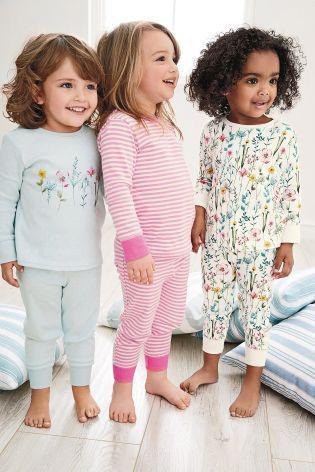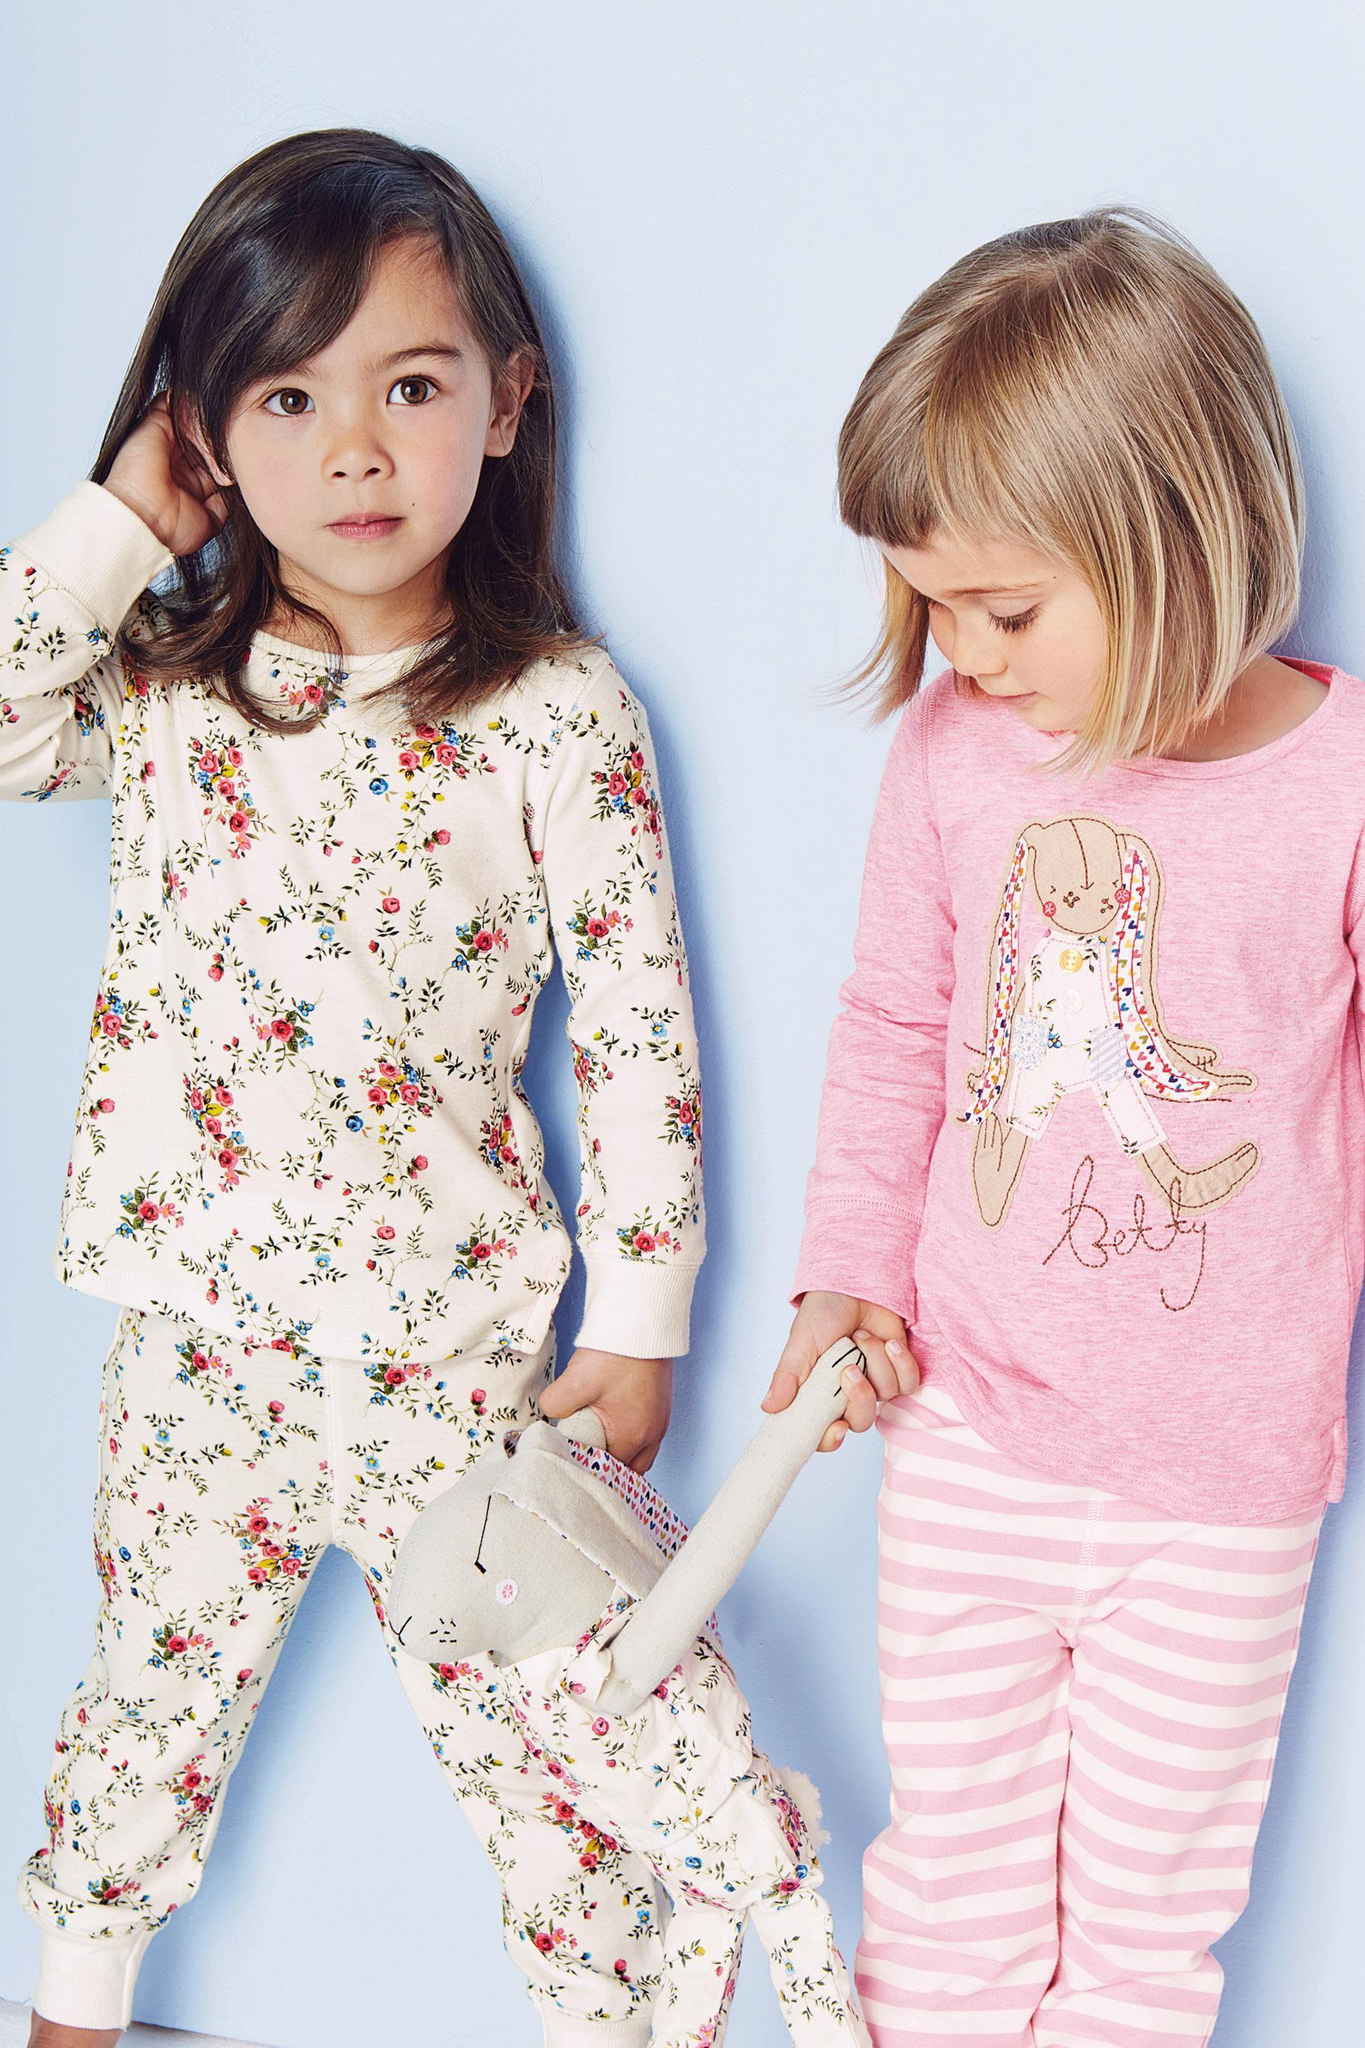The first image is the image on the left, the second image is the image on the right. Examine the images to the left and right. Is the description "There are four people in each set of images." accurate? Answer yes or no. No. 